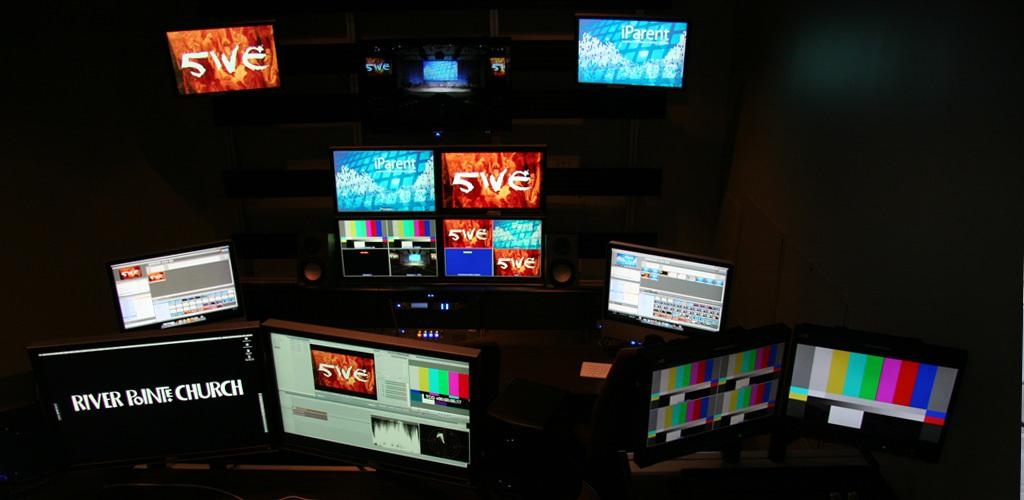<image>
Share a concise interpretation of the image provided. River Pointe Church is shown on a display with other displays in a dark room. 